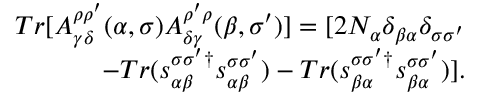<formula> <loc_0><loc_0><loc_500><loc_500>\begin{array} { r } { T r [ A _ { \gamma \delta } ^ { \rho \rho ^ { \prime } } ( \alpha , \sigma ) A _ { \delta \gamma } ^ { \rho ^ { \prime } \rho } ( \beta , \sigma ^ { \prime } ) ] = [ 2 N _ { \alpha } \delta _ { \beta \alpha } \delta _ { \sigma \sigma ^ { \prime } } } \\ { - T r ( s _ { \alpha \beta } ^ { \sigma \sigma ^ { \prime } \dagger } s _ { \alpha \beta } ^ { \sigma \sigma ^ { \prime } } ) - T r ( s _ { \beta \alpha } ^ { \sigma \sigma ^ { \prime } \dagger } s _ { \beta \alpha } ^ { \sigma \sigma ^ { \prime } } ) ] . } \end{array}</formula> 